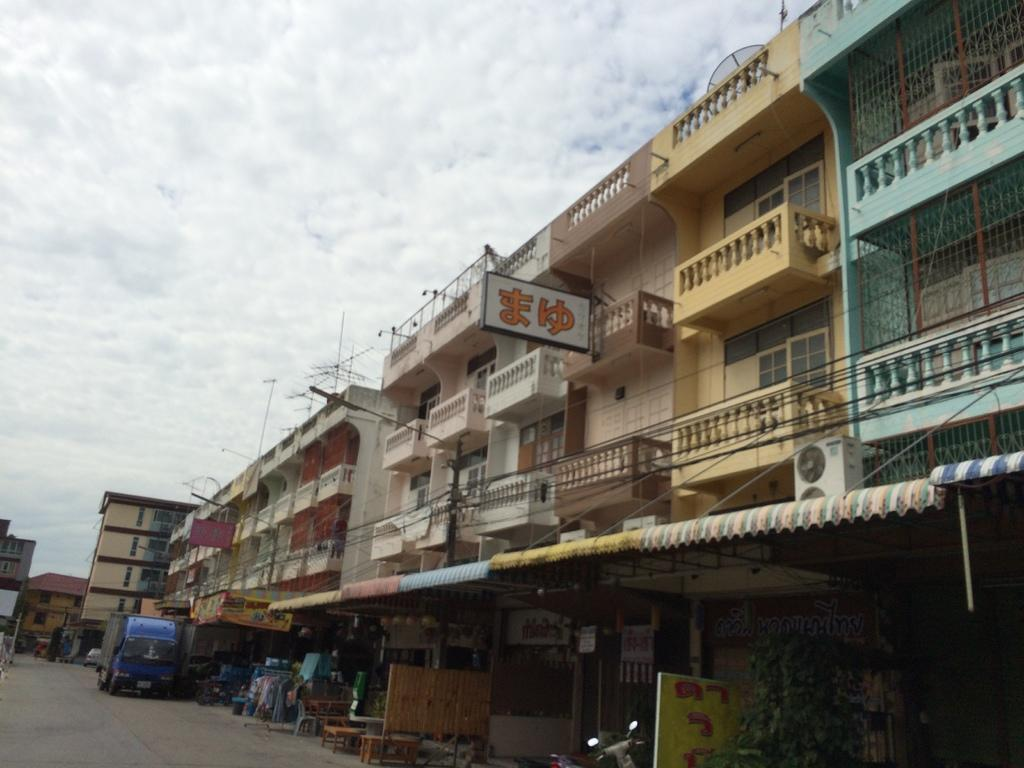What type of vehicle is present at the bottom of the image? There is a bike and a truck at the bottom of the image. What else can be seen at the bottom of the image? The bike and truck are at the bottom of the image. What is visible in the background of the image? There are buildings in the background of the image. What is visible at the top of the image? The sky is visible at the top of the image. How would you describe the sky in the image? The sky appears to be cloudy in the image. How many sheep are visible in the image? There are no sheep present in the image. What type of sink is featured in the image? There is no sink present in the image. 